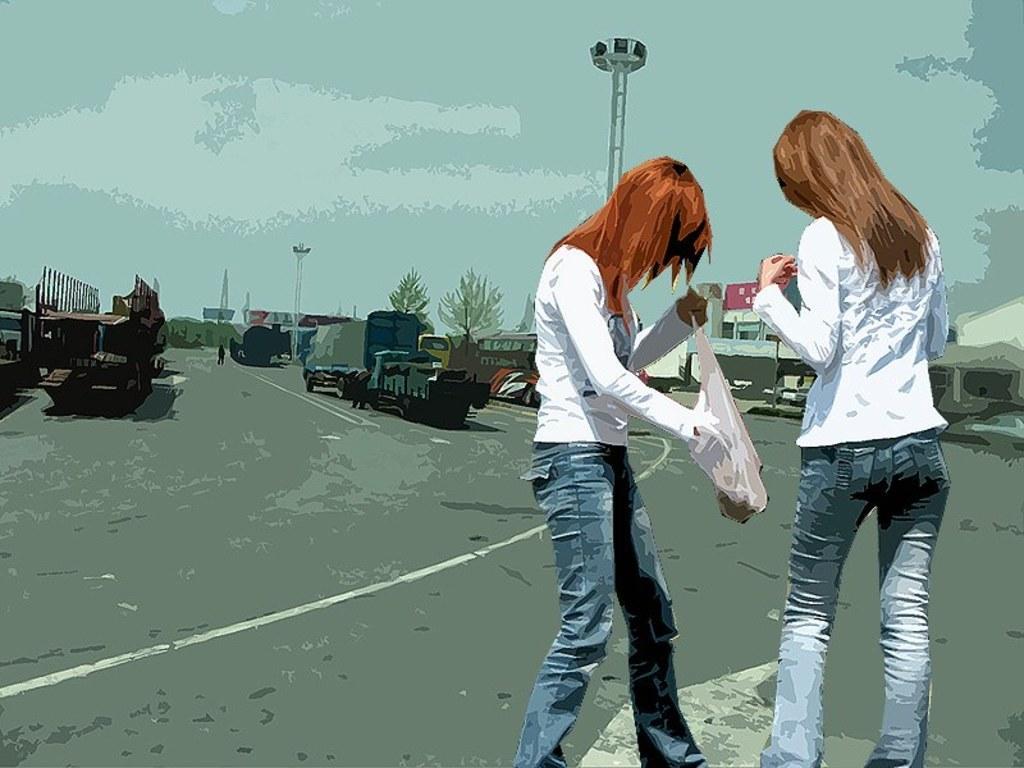Please provide a concise description of this image. In this image I can see the depiction picture. In that picture I can see two women are standing in the front and one of them is holding a cover. I can also see both of them are wearing same colour dress. In the background I can see number of vehicles on the road, few buildings, few poles, few trees and the sky. 